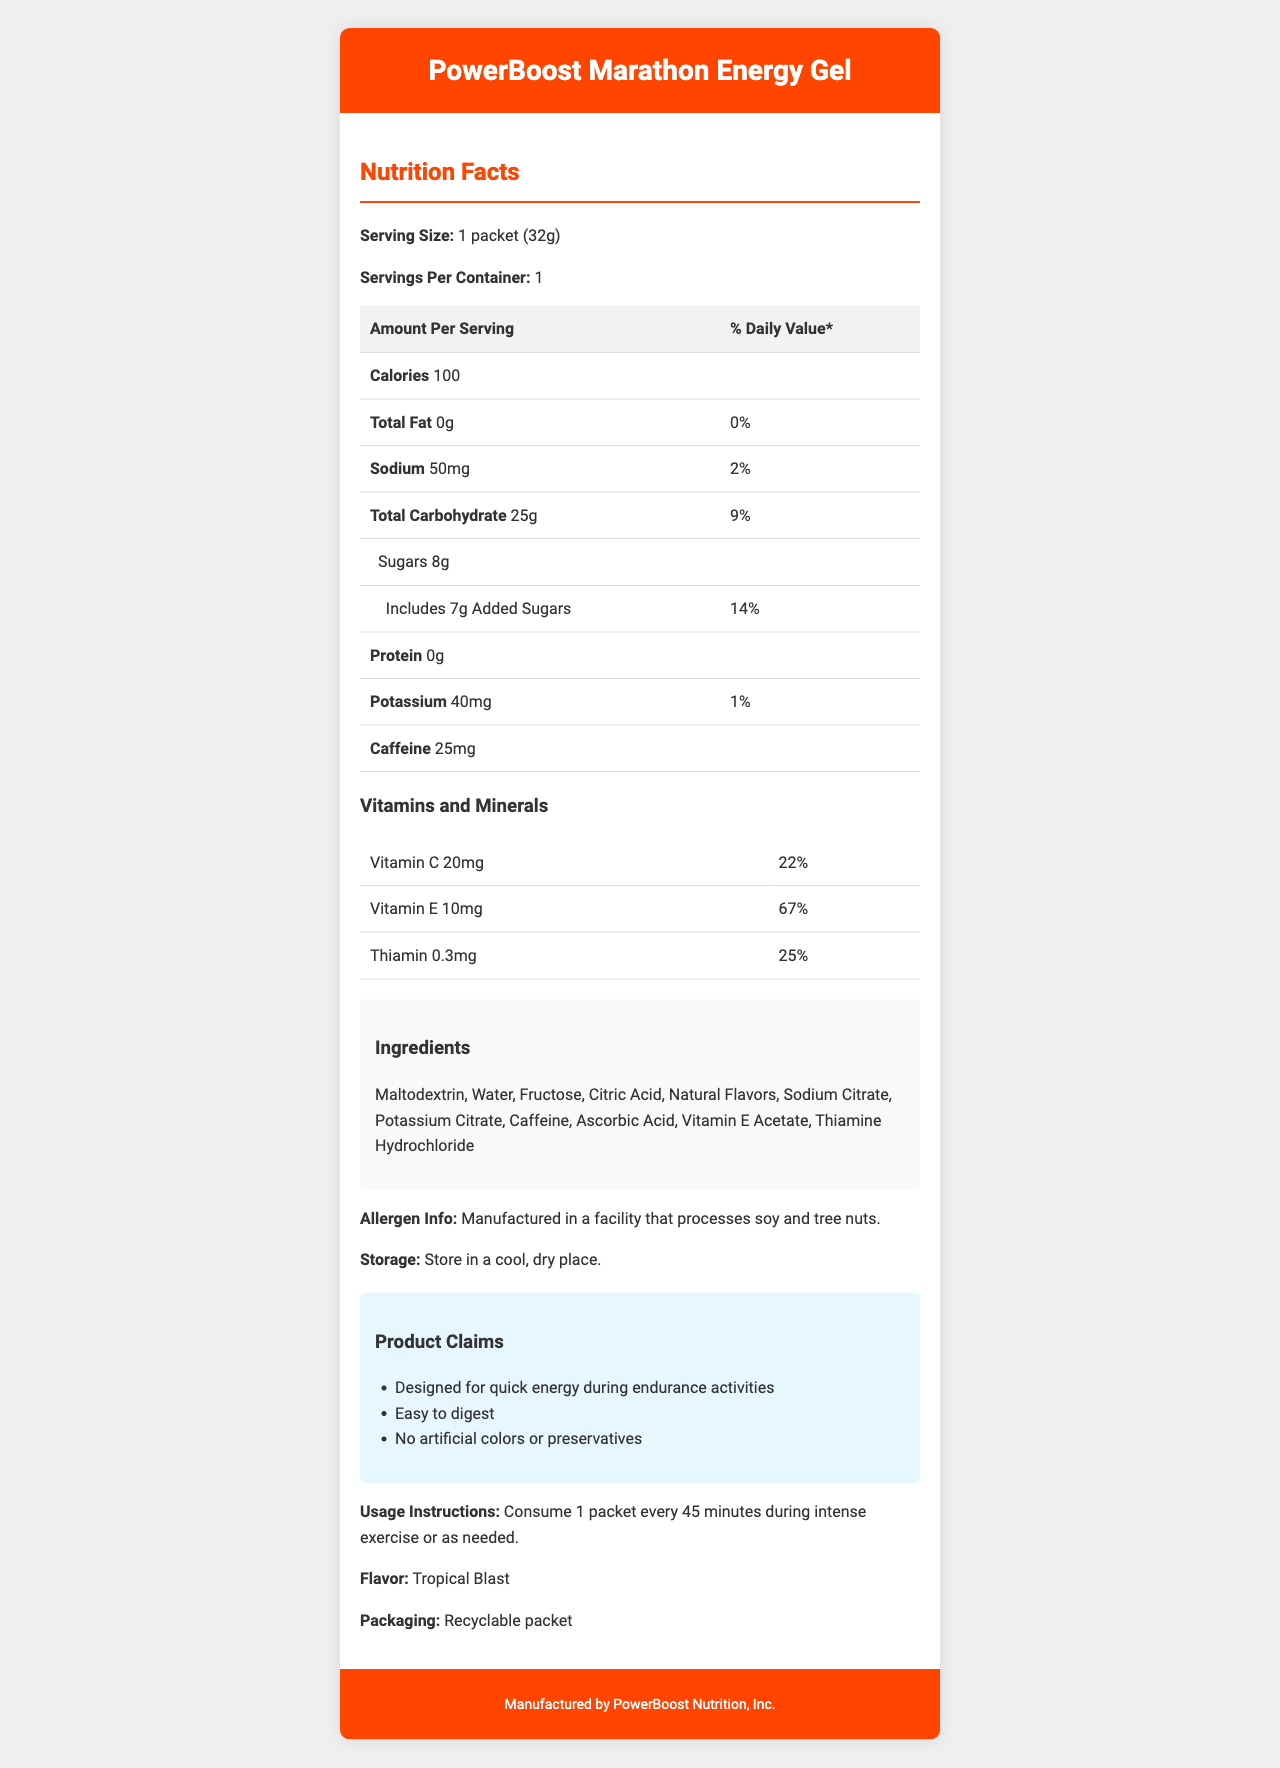what is the serving size of the PowerBoost Marathon Energy Gel? The serving size is specified as "1 packet (32g)" under the "Nutrition Facts" section.
Answer: 1 packet (32g) how many grams of total carbohydrate are in one serving? The nutrition table lists "Total Carbohydrate" as 25g per serving.
Answer: 25g how much caffeine is in each packet? The document lists caffeine as 25mg per serving.
Answer: 25mg what is the percentage of daily value for Vitamin E? Under the "Vitamins and Minerals" section, Vitamin E has a daily value of 67%.
Answer: 67% does the PowerBoost Marathon Energy Gel contain any protein? The nutrition label indicates "Protein 0g".
Answer: No how many servings per container are there? A. 1 B. 2 C. 3 D. 4 The document states "Servings Per Container: 1".
Answer: A which of the following ingredients is not in the PowerBoost Marathon Energy Gel? A. Citric Acid B. Natural Flavors C. Milk D. Ascorbic Acid The ingredients list includes Citric Acid, Natural Flavors, and Ascorbic Acid, but not Milk.
Answer: C is the packet recyclable? The section mentions "Recyclable packet" under "Packaging."
Answer: Yes summarize the main claims made about the PowerBoost Marathon Energy Gel. These claims are detailed in the "Product Claims" section.
Answer: The gel is designed for quick energy during endurance activities, easy to digest, and free from artificial colors or preservatives. what is the shelf life of the product? The document does not provide any information about the shelf life.
Answer: Not enough information what is the flavor of the PowerBoost Marathon Energy Gel? The document lists the flavor as "Tropical Blast".
Answer: Tropical Blast how many grams of sugar in total and added sugar are in one serving? The nutrition facts state 8g of sugars, and the breakdown mentions 7g of added sugars.
Answer: 8g total, 7g added how should you consume the product during intense exercise? The usage instructions specify to "Consume 1 packet every 45 minutes during intense exercise or as needed."
Answer: 1 packet every 45 minutes where is the product manufactured? The footer of the document states it is manufactured by "PowerBoost Nutrition, Inc."
Answer: PowerBoost Nutrition, Inc. list all the vitamins and their daily values provided by the gel. The "Vitamins and Minerals" section lists Vitamin C (22%), Vitamin E (67%), and Thiamin (25%).
Answer: Vitamin C (22%), Vitamin E (67%), Thiamin (25%) 